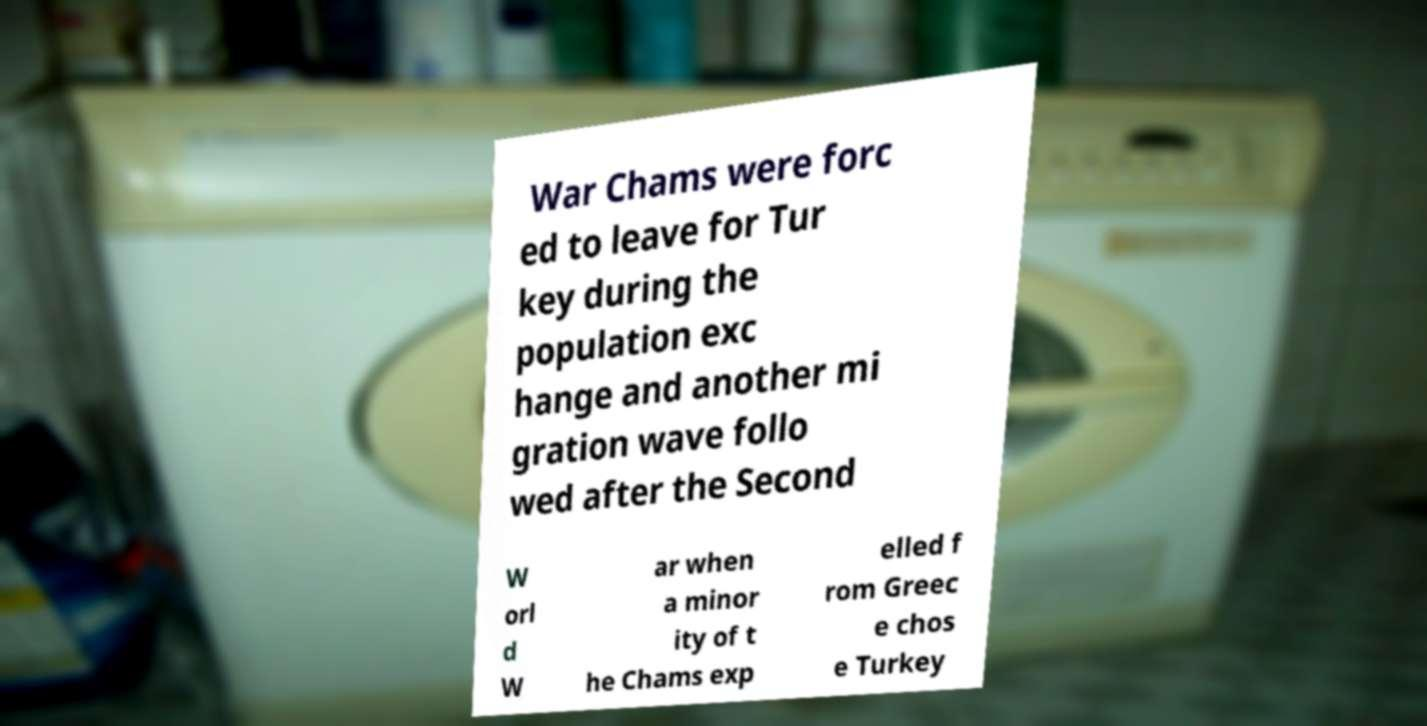For documentation purposes, I need the text within this image transcribed. Could you provide that? War Chams were forc ed to leave for Tur key during the population exc hange and another mi gration wave follo wed after the Second W orl d W ar when a minor ity of t he Chams exp elled f rom Greec e chos e Turkey 